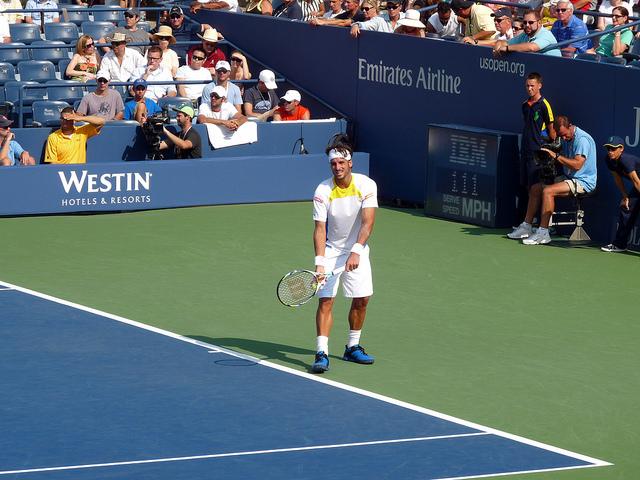What is the overall color of the player's attire?
Concise answer only. White. What is the man in yellow doing with his left hand?
Write a very short answer. Shading his eyes. Is the woman holding the ball?
Short answer required. No. What car company is named on one of the bleachers?
Write a very short answer. None. Is the tennis court blue?
Write a very short answer. Yes. What is the occupation of the two people in navy to the right of the photo?
Be succinct. Ball boys. Who is one of the sponsors of this event?
Keep it brief. Westin. What is the man in the center about to do?
Short answer required. Serve. 